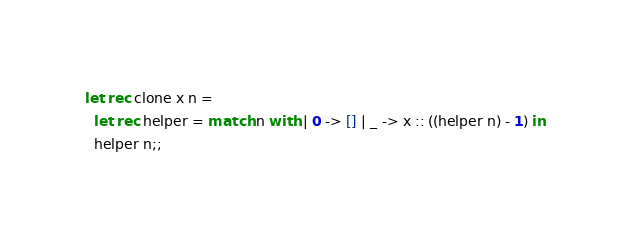Convert code to text. <code><loc_0><loc_0><loc_500><loc_500><_OCaml_>
let rec clone x n =
  let rec helper = match n with | 0 -> [] | _ -> x :: ((helper n) - 1) in
  helper n;;
</code> 